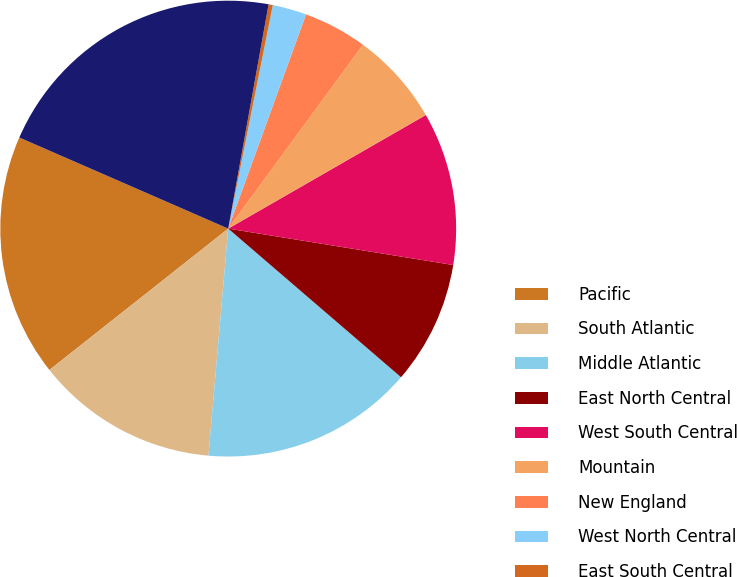<chart> <loc_0><loc_0><loc_500><loc_500><pie_chart><fcel>Pacific<fcel>South Atlantic<fcel>Middle Atlantic<fcel>East North Central<fcel>West South Central<fcel>Mountain<fcel>New England<fcel>West North Central<fcel>East South Central<fcel>Subtotal-US<nl><fcel>17.19%<fcel>12.97%<fcel>15.08%<fcel>8.75%<fcel>10.86%<fcel>6.63%<fcel>4.52%<fcel>2.41%<fcel>0.3%<fcel>21.29%<nl></chart> 